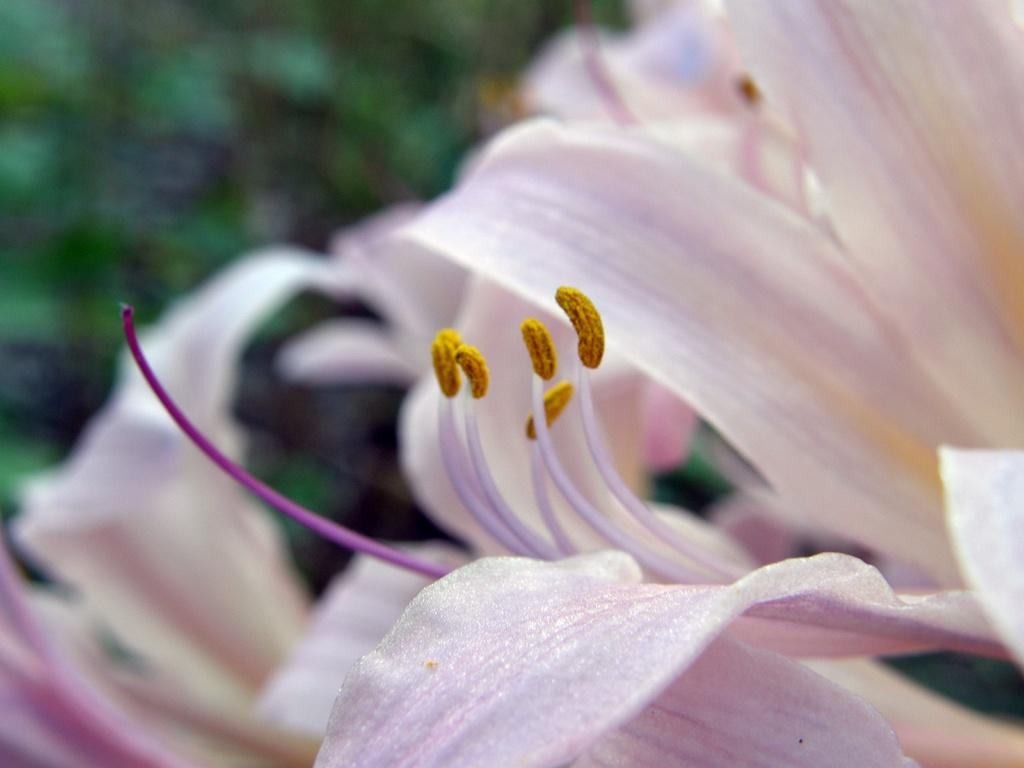What is the main subject of the image? There is a flower in the image. Can you describe the background of the image? The background of the image is green and blurred. What color is the paint on the friend's shirt in the image? There is no friend or paint present in the image; it only features a flower and a green, blurred background. 